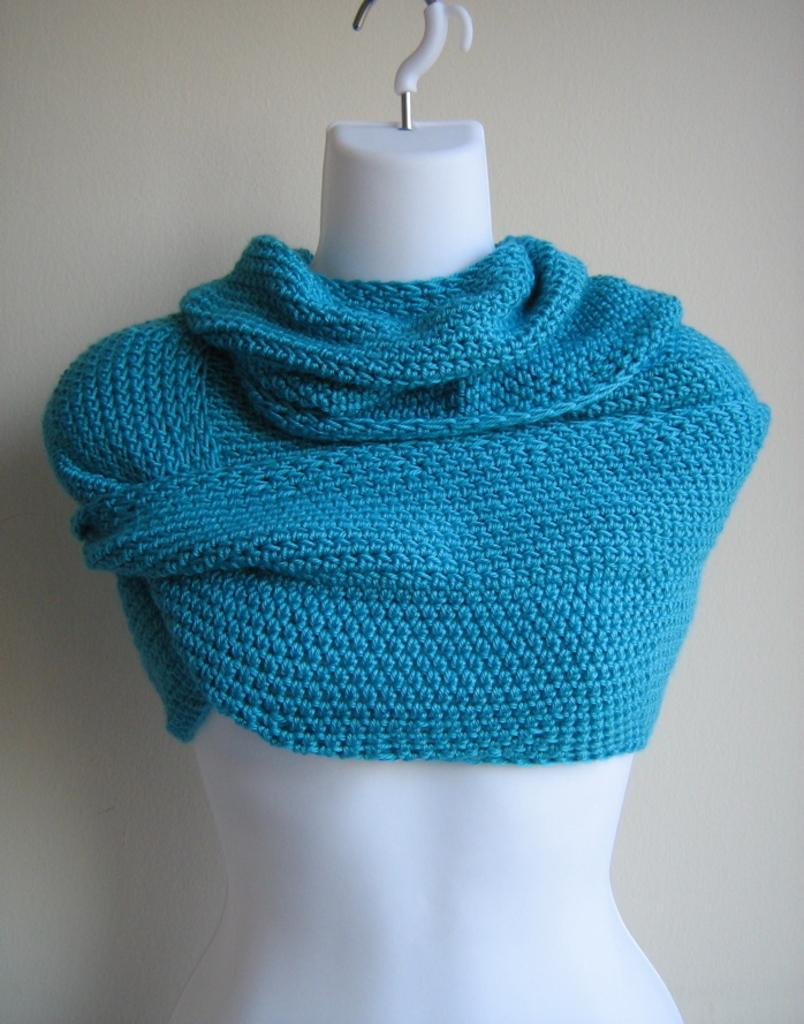What is the main subject in the center of the image? There is a mannequin in the center of the image. What type of material is present in the image? Cloth is present in the image. What can be seen in the background of the image? There is a wall in the background of the image. What type of pot is being used to cook bread in the image? There is no pot or bread present in the image; it only features a mannequin and cloth. 